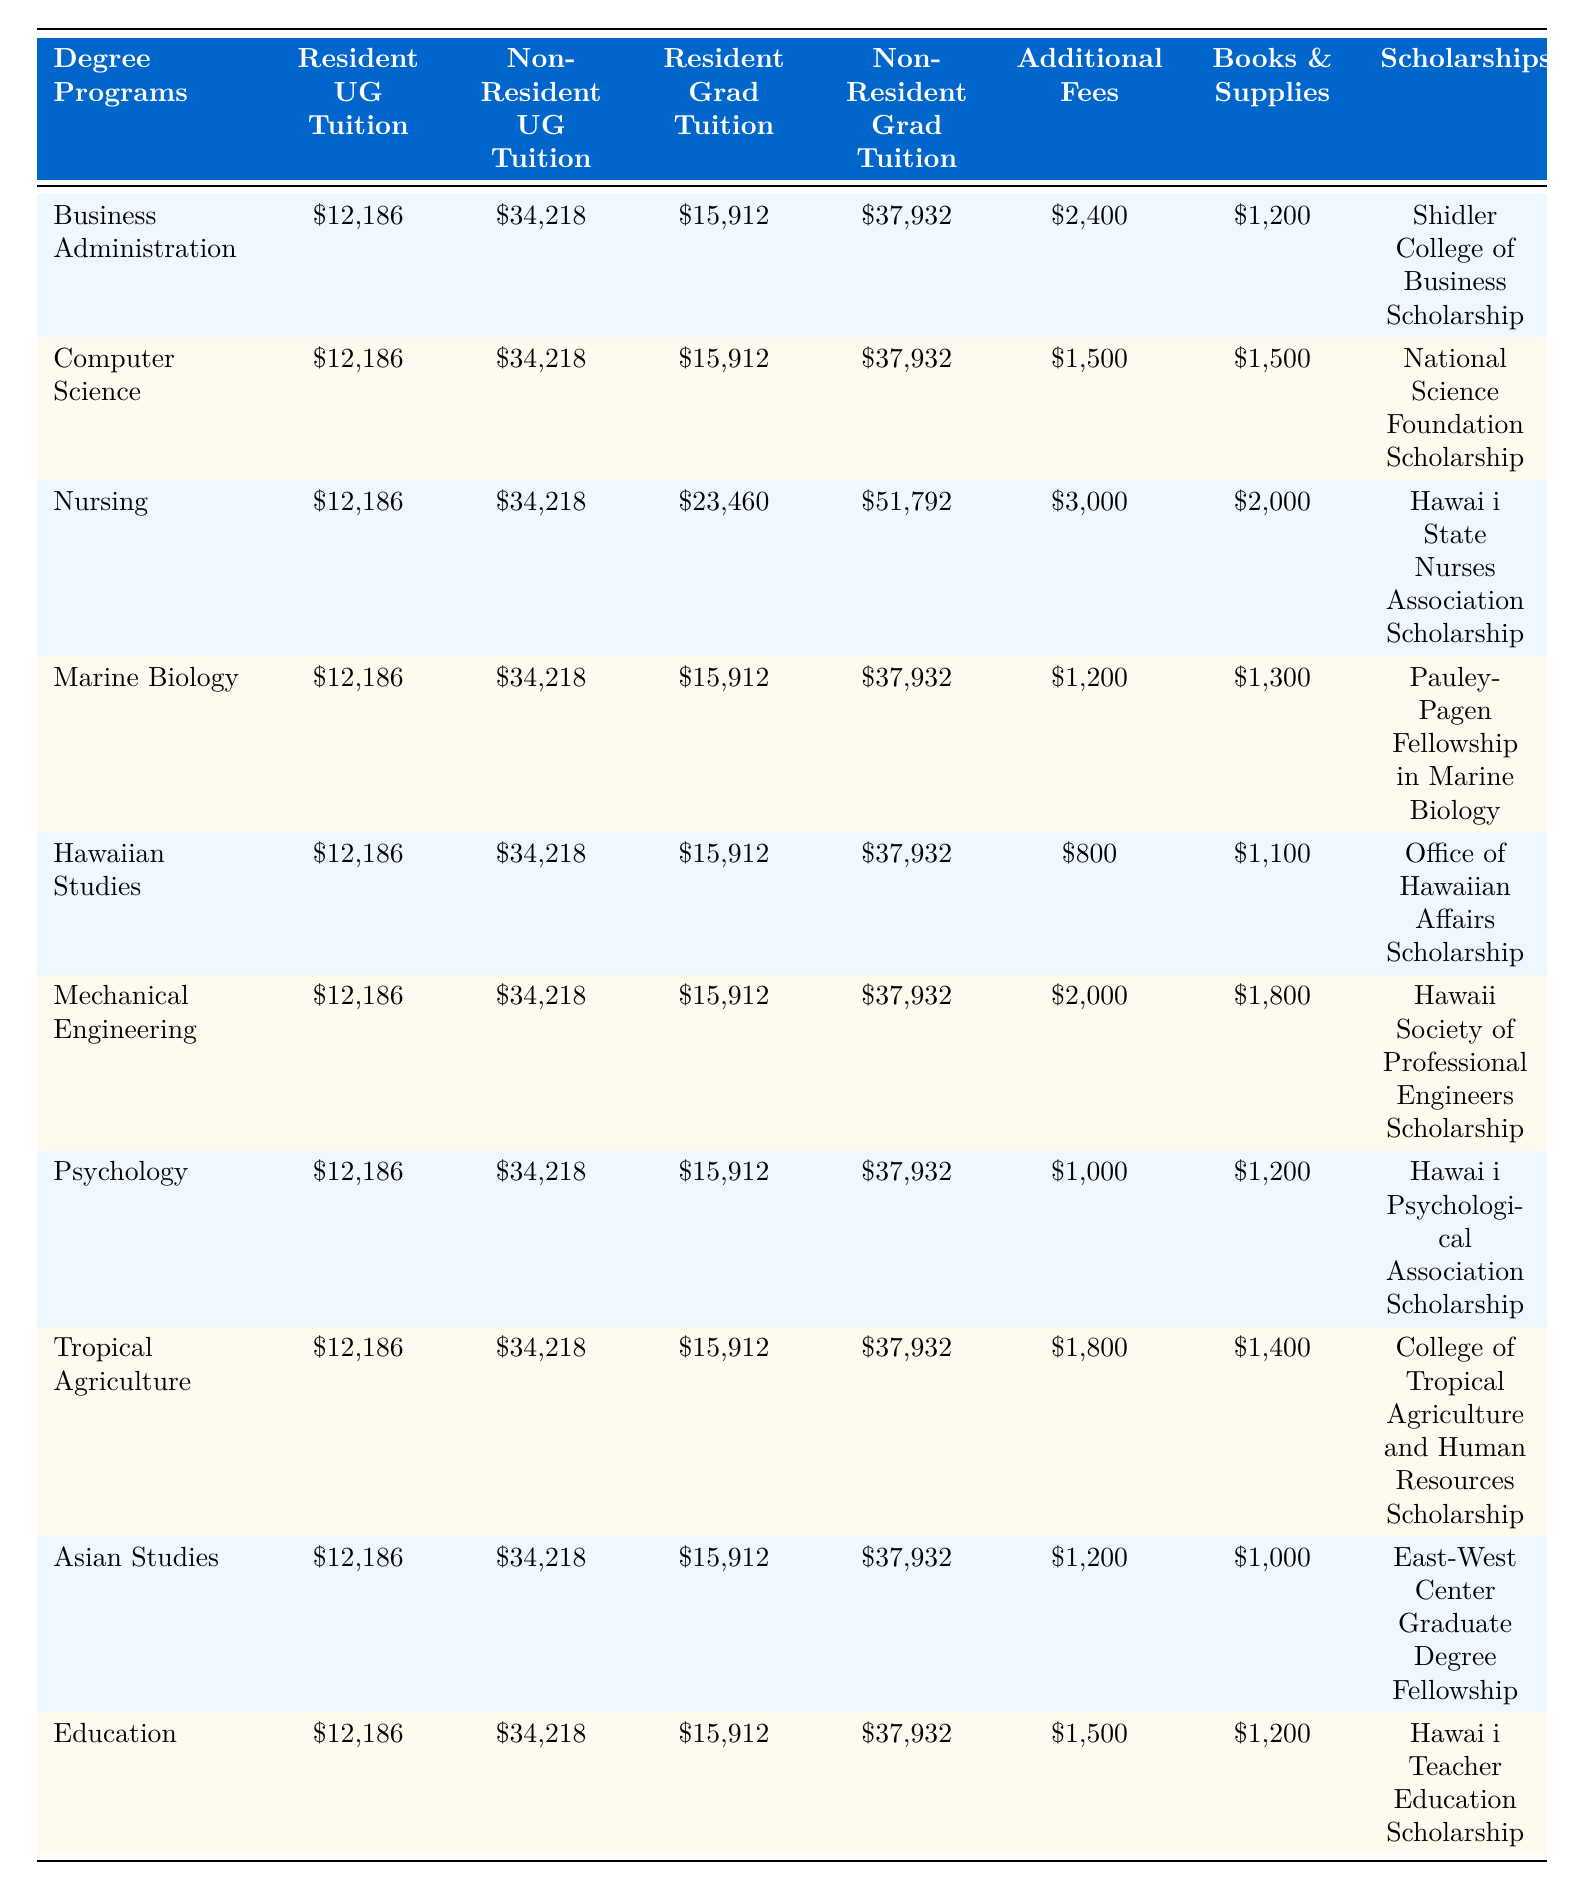What is the tuition fee for Resident Undergraduate students in Nursing? The table indicates that the tuition fee for Resident Undergraduate students in the Nursing program is mentioned in the "Resident Undergraduate Tuition (per year)" column under "Nursing," which is \$12,186.
Answer: \$12,186 What is the cost of Additional Program Fees for Computer Science? In the table, the Additional Program Fees for the Computer Science degree can be found in the corresponding row under the "Additional Program Fees (per year)" column, which lists \$1,500.
Answer: \$1,500 Are the Resident and Non-Resident Undergraduate tuition fees the same for all degree programs? By examining the "Resident Undergraduate Tuition (per year)" and "Non-Resident Undergraduate Tuition (per year)" columns, we see that the values are constant for all the programs: \$12,186 for residents and \$34,218 for non-residents. Thus, the tuition fees are the same across all programs for both categories.
Answer: Yes What is the difference in tuition fees between Resident and Non-Resident Graduate students for the Nursing program? For Nursing, the "Resident Graduate Tuition (per year)" is \$23,460 and the "Non-Resident Graduate Tuition (per year)" is \$51,792. The difference is calculated by subtracting the resident fee from the non-resident fee: \$51,792 - \$23,460 = \$28,332.
Answer: \$28,332 Which degree program has the highest estimated cost for Books and Supplies? The "Estimated Books and Supplies Cost (per year)" column shows the values for each program. Scanning this column, we find that Nursing has the highest cost at \$2,000, compared to other programs.
Answer: Nursing What is the average tuition fee for Non-Resident Graduate students across all degree programs? The "Non-Resident Graduate Tuition (per year)" for all programs is the same at \$37,932, and since there are 10 degree programs, the average is: \$37,932. (Since they are all identical, the average remains the same as the individual fee.)
Answer: \$37,932 Which degree program offers the lowest Additional Program Fees? By looking at the "Additional Program Fees (per year)" column, we identify the lowest fee at \$800 associated with the Hawaiian Studies program.
Answer: Hawaiian Studies What is the total cost (tuition plus Additional Fees plus estimated Books and Supplies) for Non-Resident Graduate students in Mechanical Engineering? For Mechanical Engineering, we add the Non-Resident Graduate Tuition (\$37,932), Additional Program Fees (\$2,000), and the estimated Books and Supplies Cost (\$1,800). The total cost calculation is: \$37,932 + \$2,000 + \$1,800 = \$41,732.
Answer: \$41,732 Are there any scholarships specifically for programs outside of the business and health fields? By reviewing the "Scholarships Available" column, we can identify that programs like Marine Biology, Hawaiian Studies, and Tropical Agriculture have scholarships that are not related to business or health fields.
Answer: Yes Which program has the highest total estimated cost (including all tuition, fees, and books/supplies) for Resident Graduate students? For Resident Graduate students, we first locate the tuition (\$15,912) for each program, add it to the Additional Program Fees and Books/Supplies Costs. The calculations will indicate Nursing has the highest total at: \$23,460 + \$3,000 + \$2,000 = \$28,460.
Answer: Nursing 